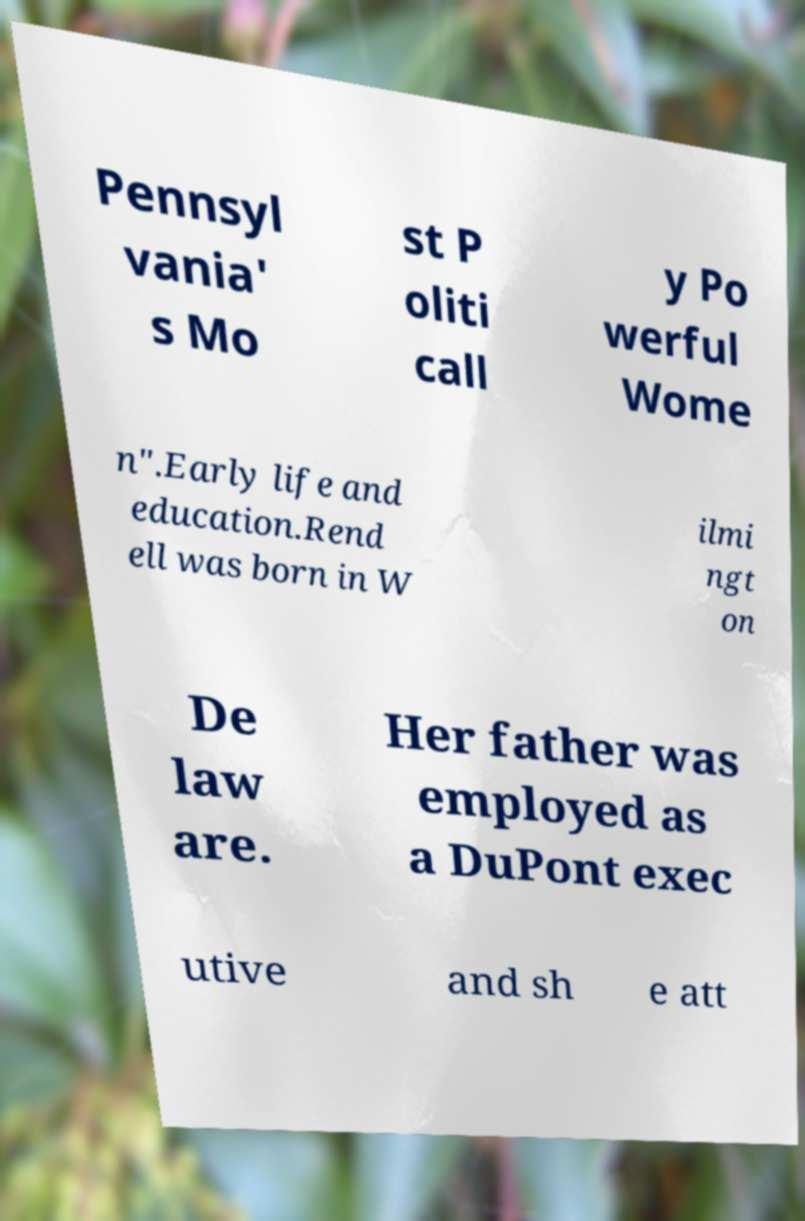Could you assist in decoding the text presented in this image and type it out clearly? Pennsyl vania' s Mo st P oliti call y Po werful Wome n".Early life and education.Rend ell was born in W ilmi ngt on De law are. Her father was employed as a DuPont exec utive and sh e att 